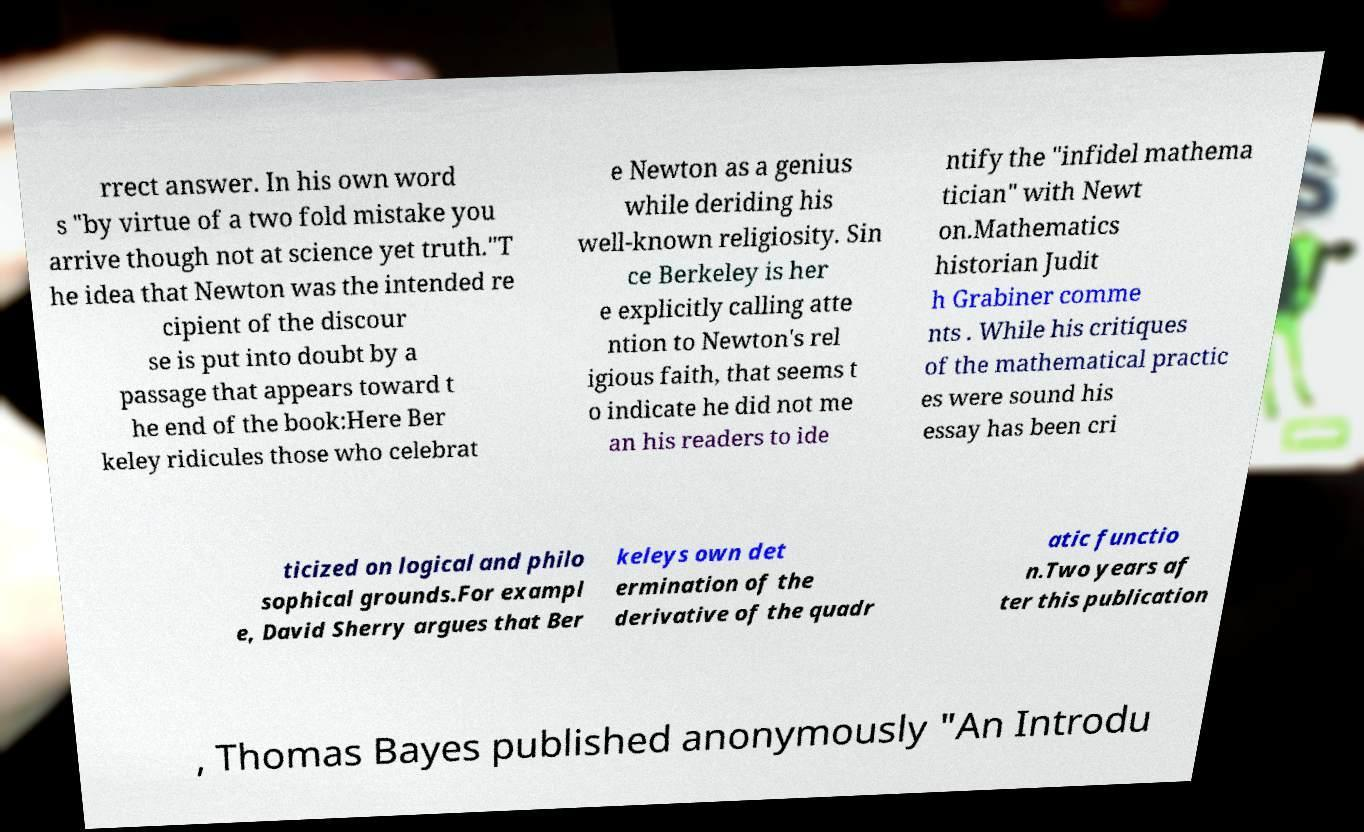Can you accurately transcribe the text from the provided image for me? rrect answer. In his own word s "by virtue of a two fold mistake you arrive though not at science yet truth."T he idea that Newton was the intended re cipient of the discour se is put into doubt by a passage that appears toward t he end of the book:Here Ber keley ridicules those who celebrat e Newton as a genius while deriding his well-known religiosity. Sin ce Berkeley is her e explicitly calling atte ntion to Newton's rel igious faith, that seems t o indicate he did not me an his readers to ide ntify the "infidel mathema tician" with Newt on.Mathematics historian Judit h Grabiner comme nts . While his critiques of the mathematical practic es were sound his essay has been cri ticized on logical and philo sophical grounds.For exampl e, David Sherry argues that Ber keleys own det ermination of the derivative of the quadr atic functio n.Two years af ter this publication , Thomas Bayes published anonymously "An Introdu 